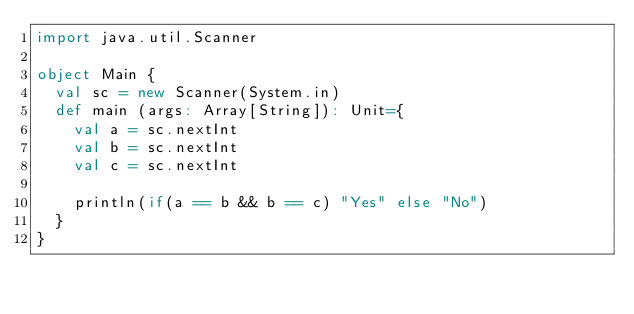Convert code to text. <code><loc_0><loc_0><loc_500><loc_500><_Scala_>import java.util.Scanner

object Main {
  val sc = new Scanner(System.in)
  def main (args: Array[String]): Unit={
    val a = sc.nextInt
    val b = sc.nextInt
    val c = sc.nextInt

    println(if(a == b && b == c) "Yes" else "No")
  }
}

</code> 